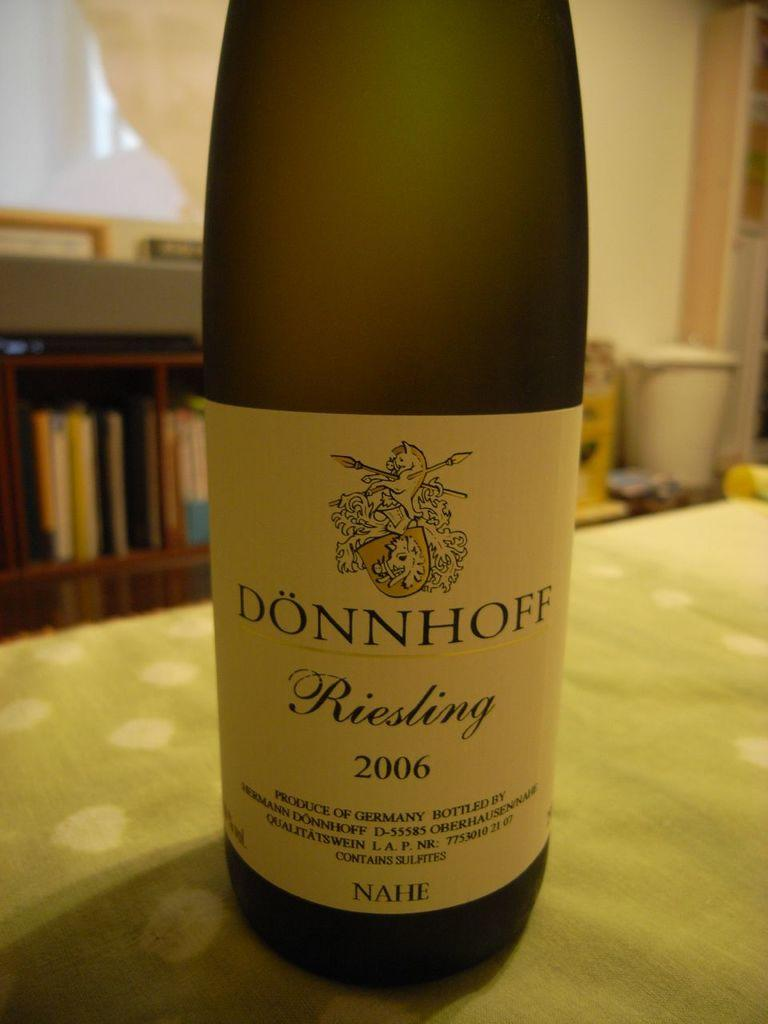<image>
Write a terse but informative summary of the picture. A bottle of Donnhoff wine stands on a kitchen table. 